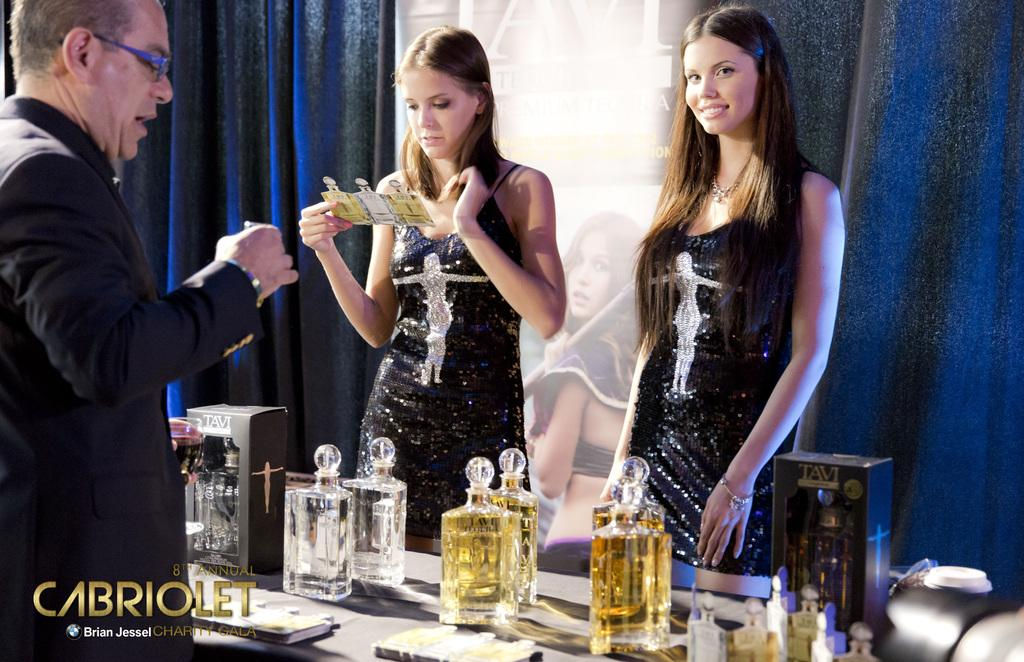<image>
Present a compact description of the photo's key features. Two women and a man attend the eighth annual Cabriole event. 